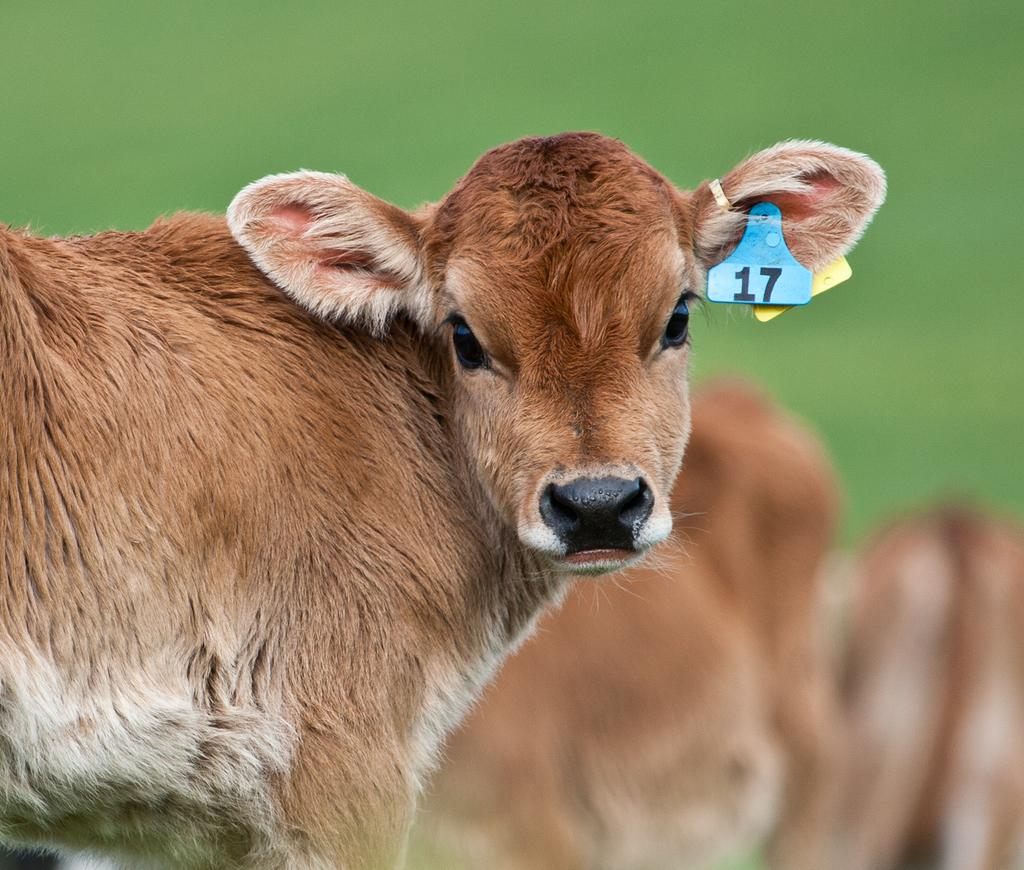What is the main subject in the foreground of the picture? There is a calf in the foreground of the picture. Can you describe any unique features of the calf? The calf has piercings on its ears. How would you describe the background of the image? The background of the image is blurred. What grade did the calf receive on its last report card? The image does not contain any information about the calf's report card or grades, as it is a photograph of a calf with piercings. 